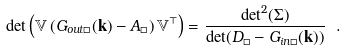<formula> <loc_0><loc_0><loc_500><loc_500>\det \left ( \mathbb { V } \left ( G _ { o u t \Box } ( \mathbf k ) - A _ { \Box } \right ) \mathbb { V } ^ { \top } \right ) = \frac { \det ^ { 2 } ( \Sigma ) } { \det ( D _ { \Box } - G _ { i n \Box } ( \mathbf k ) ) } \ .</formula> 